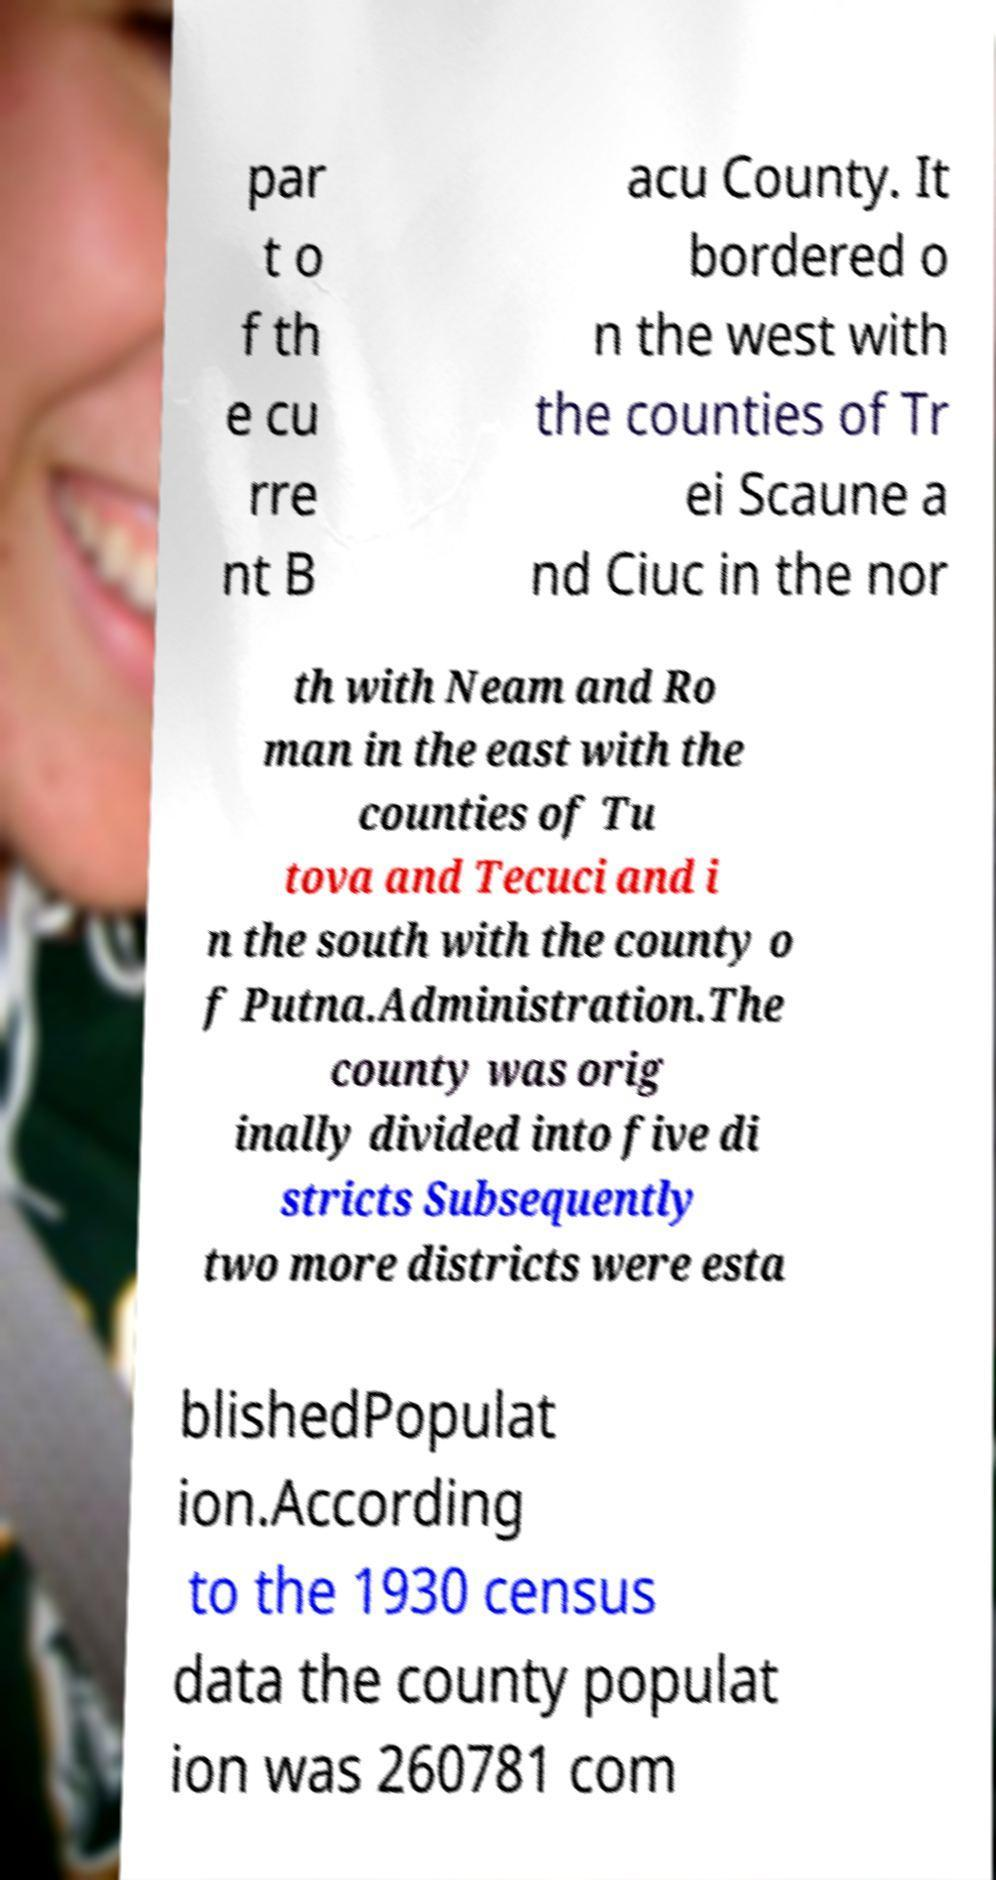What messages or text are displayed in this image? I need them in a readable, typed format. par t o f th e cu rre nt B acu County. It bordered o n the west with the counties of Tr ei Scaune a nd Ciuc in the nor th with Neam and Ro man in the east with the counties of Tu tova and Tecuci and i n the south with the county o f Putna.Administration.The county was orig inally divided into five di stricts Subsequently two more districts were esta blishedPopulat ion.According to the 1930 census data the county populat ion was 260781 com 